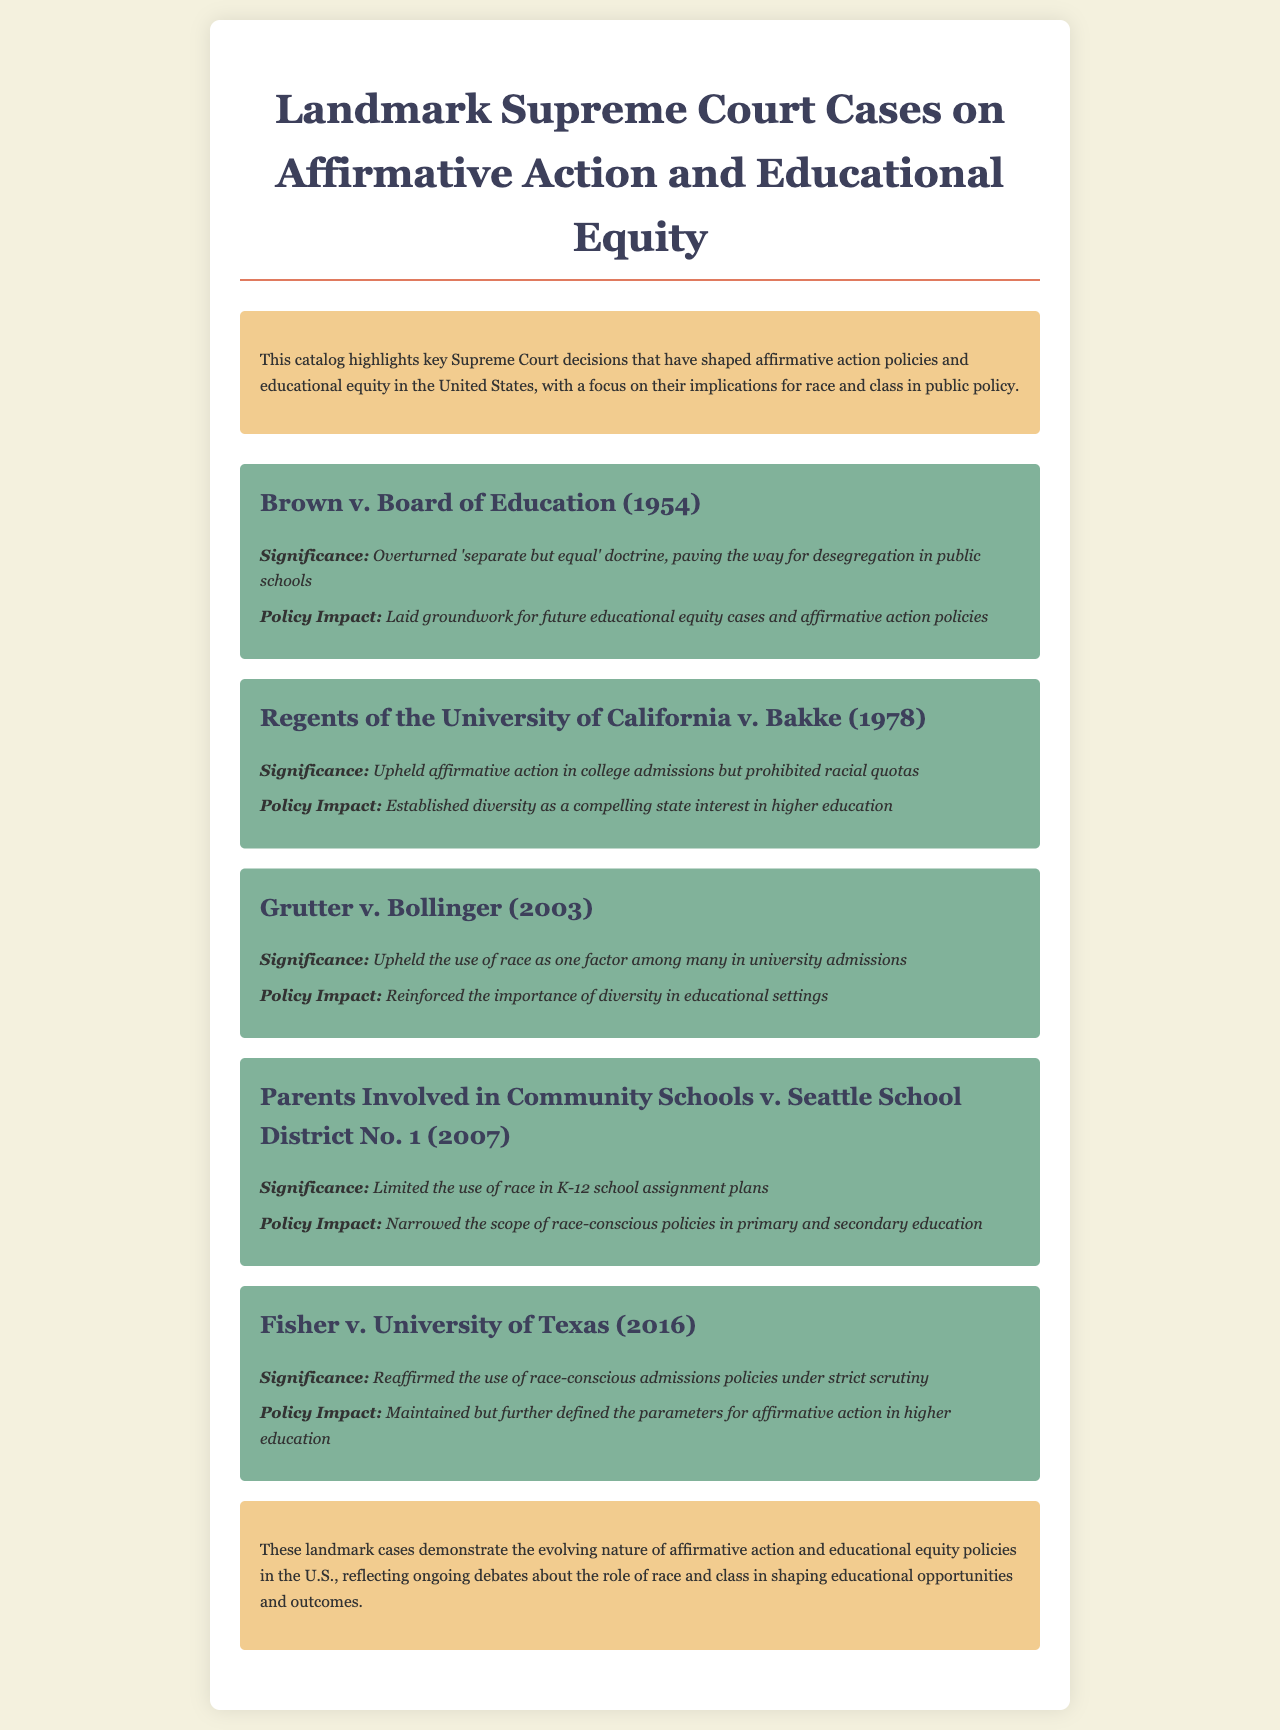What is the title of the document? The title of the document is stated in the header section, which is "Landmark Supreme Court Cases on Affirmative Action and Educational Equity."
Answer: Landmark Supreme Court Cases on Affirmative Action and Educational Equity What year was Brown v. Board of Education decided? The year of the case is mentioned following the title, which is 1954.
Answer: 1954 What legal doctrine did Brown v. Board of Education overturn? The document specifies that this case overturned the 'separate but equal' doctrine.
Answer: 'separate but equal' What was the main outcome of Regents of the University of California v. Bakke? The document indicates that the main outcome was to uphold affirmative action in college admissions but prohibit racial quotas.
Answer: upheld affirmative action but prohibited racial quotas Which case limited the use of race in K-12 school assignments? The document clearly states that Parents Involved in Community Schools v. Seattle School District No. 1 limited the use of race in school assignment plans.
Answer: Parents Involved in Community Schools v. Seattle School District No. 1 What significant concept did Grutter v. Bollinger reinforce? According to the document, Grutter v. Bollinger reinforced the importance of diversity in educational settings.
Answer: importance of diversity How many cases are discussed in the document? The number of cases can be counted from the document and is specified to be five.
Answer: five What does the conclusion highlight? The conclusion summarizes the overall themes discussed and mentions the evolving nature of affirmative action and educational equity policies.
Answer: evolving nature of affirmative action and educational equity policies 